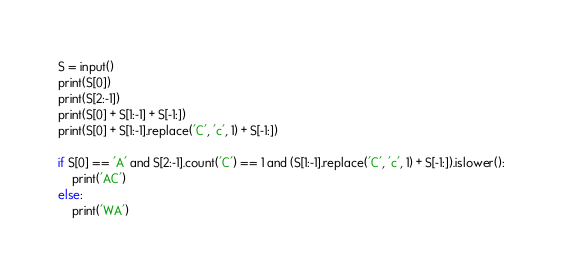Convert code to text. <code><loc_0><loc_0><loc_500><loc_500><_Python_>S = input()
print(S[0])
print(S[2:-1])
print(S[0] + S[1:-1] + S[-1:])
print(S[0] + S[1:-1].replace('C', 'c', 1) + S[-1:])

if S[0] == 'A' and S[2:-1].count('C') == 1 and (S[1:-1].replace('C', 'c', 1) + S[-1:]).islower():
    print('AC')
else:
    print('WA')

</code> 